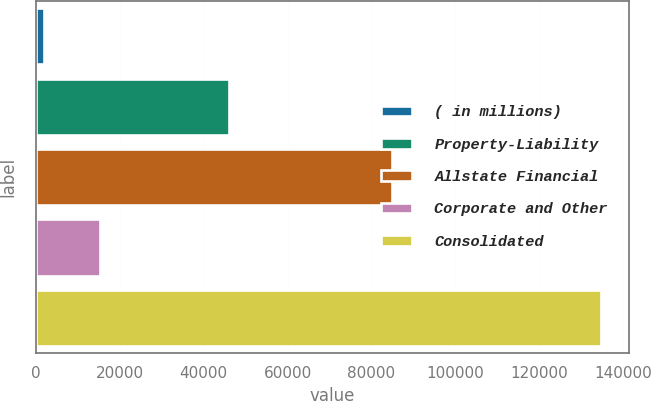Convert chart. <chart><loc_0><loc_0><loc_500><loc_500><bar_chart><fcel>( in millions)<fcel>Property-Liability<fcel>Allstate Financial<fcel>Corporate and Other<fcel>Consolidated<nl><fcel>2008<fcel>45967<fcel>84929<fcel>15287<fcel>134798<nl></chart> 